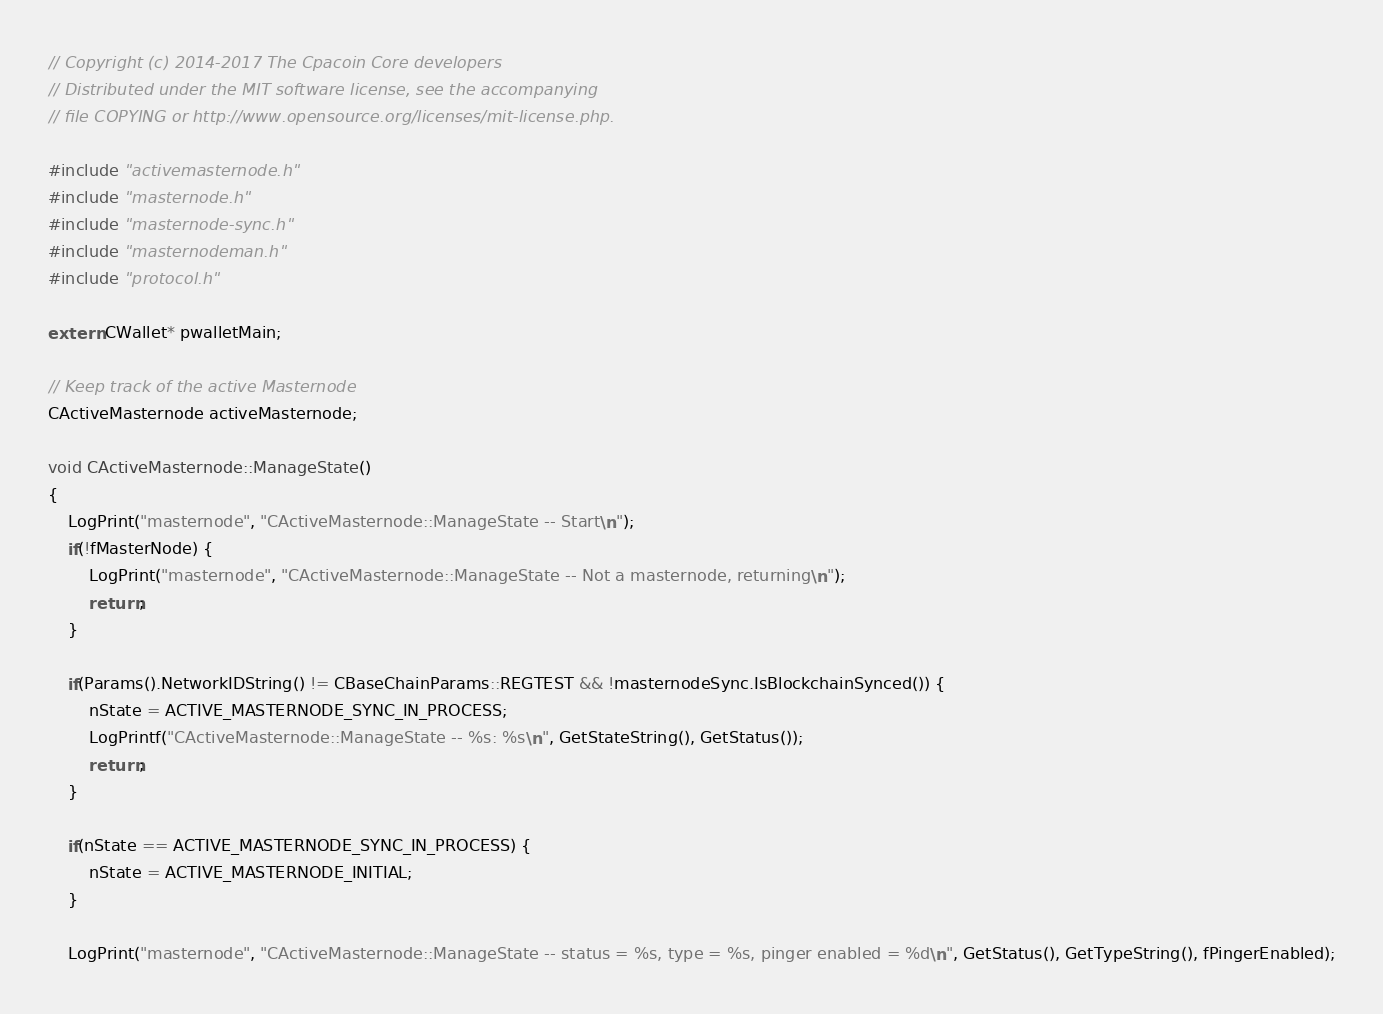<code> <loc_0><loc_0><loc_500><loc_500><_C++_>// Copyright (c) 2014-2017 The Cpacoin Core developers
// Distributed under the MIT software license, see the accompanying
// file COPYING or http://www.opensource.org/licenses/mit-license.php.

#include "activemasternode.h"
#include "masternode.h"
#include "masternode-sync.h"
#include "masternodeman.h"
#include "protocol.h"

extern CWallet* pwalletMain;

// Keep track of the active Masternode
CActiveMasternode activeMasternode;

void CActiveMasternode::ManageState()
{
    LogPrint("masternode", "CActiveMasternode::ManageState -- Start\n");
    if(!fMasterNode) {
        LogPrint("masternode", "CActiveMasternode::ManageState -- Not a masternode, returning\n");
        return;
    }

    if(Params().NetworkIDString() != CBaseChainParams::REGTEST && !masternodeSync.IsBlockchainSynced()) {
        nState = ACTIVE_MASTERNODE_SYNC_IN_PROCESS;
        LogPrintf("CActiveMasternode::ManageState -- %s: %s\n", GetStateString(), GetStatus());
        return;
    }

    if(nState == ACTIVE_MASTERNODE_SYNC_IN_PROCESS) {
        nState = ACTIVE_MASTERNODE_INITIAL;
    }

    LogPrint("masternode", "CActiveMasternode::ManageState -- status = %s, type = %s, pinger enabled = %d\n", GetStatus(), GetTypeString(), fPingerEnabled);
</code> 